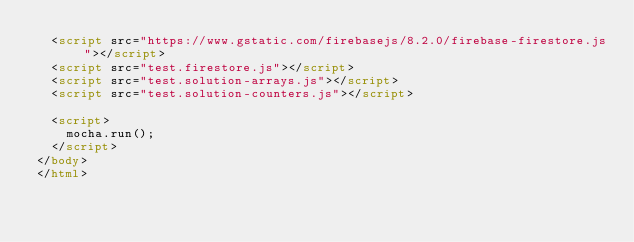<code> <loc_0><loc_0><loc_500><loc_500><_HTML_>  <script src="https://www.gstatic.com/firebasejs/8.2.0/firebase-firestore.js"></script>
  <script src="test.firestore.js"></script>
  <script src="test.solution-arrays.js"></script>
  <script src="test.solution-counters.js"></script>

  <script>
    mocha.run();
  </script>
</body>
</html>
</code> 